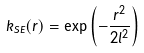<formula> <loc_0><loc_0><loc_500><loc_500>k _ { S E } ( r ) = \exp \left ( - \frac { r ^ { 2 } } { 2 l ^ { 2 } } \right )</formula> 